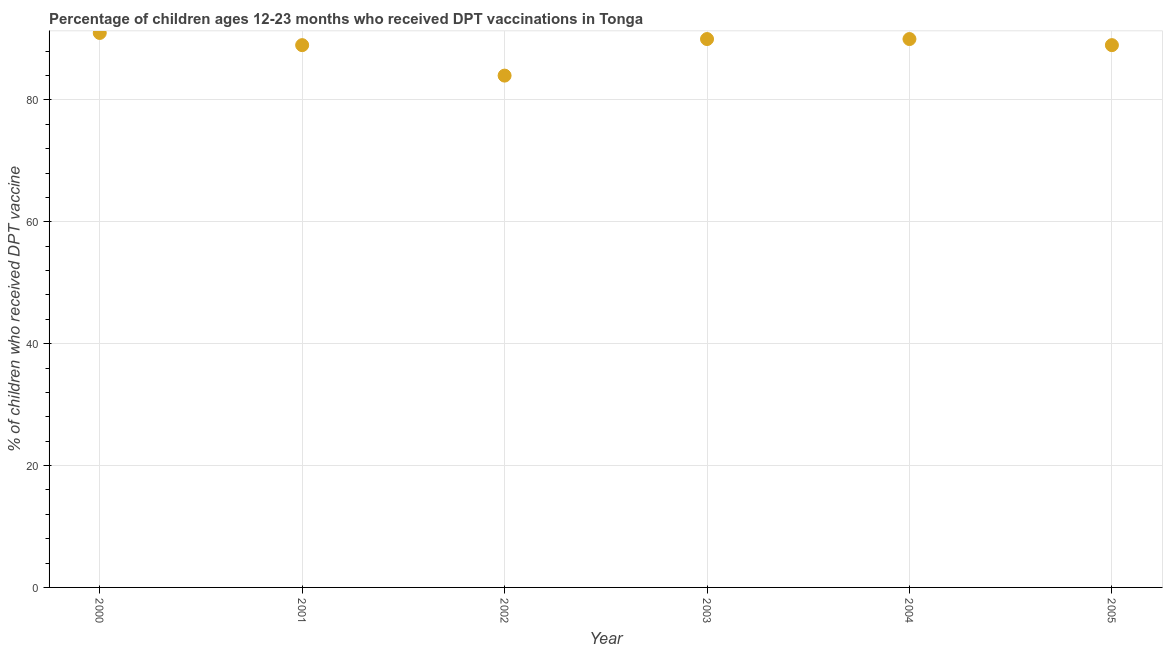What is the percentage of children who received dpt vaccine in 2000?
Give a very brief answer. 91. Across all years, what is the maximum percentage of children who received dpt vaccine?
Offer a very short reply. 91. Across all years, what is the minimum percentage of children who received dpt vaccine?
Your answer should be compact. 84. In which year was the percentage of children who received dpt vaccine maximum?
Offer a terse response. 2000. In which year was the percentage of children who received dpt vaccine minimum?
Provide a short and direct response. 2002. What is the sum of the percentage of children who received dpt vaccine?
Offer a very short reply. 533. What is the difference between the percentage of children who received dpt vaccine in 2001 and 2002?
Make the answer very short. 5. What is the average percentage of children who received dpt vaccine per year?
Your response must be concise. 88.83. What is the median percentage of children who received dpt vaccine?
Your response must be concise. 89.5. What is the ratio of the percentage of children who received dpt vaccine in 2000 to that in 2002?
Ensure brevity in your answer.  1.08. Is the difference between the percentage of children who received dpt vaccine in 2000 and 2003 greater than the difference between any two years?
Make the answer very short. No. What is the difference between the highest and the second highest percentage of children who received dpt vaccine?
Offer a terse response. 1. Is the sum of the percentage of children who received dpt vaccine in 2003 and 2005 greater than the maximum percentage of children who received dpt vaccine across all years?
Your answer should be compact. Yes. What is the difference between the highest and the lowest percentage of children who received dpt vaccine?
Your answer should be very brief. 7. How many dotlines are there?
Your answer should be compact. 1. What is the difference between two consecutive major ticks on the Y-axis?
Ensure brevity in your answer.  20. Are the values on the major ticks of Y-axis written in scientific E-notation?
Keep it short and to the point. No. Does the graph contain grids?
Your answer should be very brief. Yes. What is the title of the graph?
Your answer should be compact. Percentage of children ages 12-23 months who received DPT vaccinations in Tonga. What is the label or title of the X-axis?
Give a very brief answer. Year. What is the label or title of the Y-axis?
Give a very brief answer. % of children who received DPT vaccine. What is the % of children who received DPT vaccine in 2000?
Provide a short and direct response. 91. What is the % of children who received DPT vaccine in 2001?
Your answer should be compact. 89. What is the % of children who received DPT vaccine in 2005?
Your answer should be compact. 89. What is the difference between the % of children who received DPT vaccine in 2000 and 2002?
Keep it short and to the point. 7. What is the difference between the % of children who received DPT vaccine in 2000 and 2003?
Provide a short and direct response. 1. What is the difference between the % of children who received DPT vaccine in 2001 and 2003?
Provide a succinct answer. -1. What is the difference between the % of children who received DPT vaccine in 2001 and 2004?
Ensure brevity in your answer.  -1. What is the difference between the % of children who received DPT vaccine in 2002 and 2003?
Your response must be concise. -6. What is the difference between the % of children who received DPT vaccine in 2003 and 2004?
Ensure brevity in your answer.  0. What is the difference between the % of children who received DPT vaccine in 2004 and 2005?
Give a very brief answer. 1. What is the ratio of the % of children who received DPT vaccine in 2000 to that in 2002?
Offer a terse response. 1.08. What is the ratio of the % of children who received DPT vaccine in 2001 to that in 2002?
Offer a very short reply. 1.06. What is the ratio of the % of children who received DPT vaccine in 2001 to that in 2003?
Give a very brief answer. 0.99. What is the ratio of the % of children who received DPT vaccine in 2001 to that in 2004?
Your response must be concise. 0.99. What is the ratio of the % of children who received DPT vaccine in 2001 to that in 2005?
Give a very brief answer. 1. What is the ratio of the % of children who received DPT vaccine in 2002 to that in 2003?
Your answer should be compact. 0.93. What is the ratio of the % of children who received DPT vaccine in 2002 to that in 2004?
Your answer should be very brief. 0.93. What is the ratio of the % of children who received DPT vaccine in 2002 to that in 2005?
Ensure brevity in your answer.  0.94. 